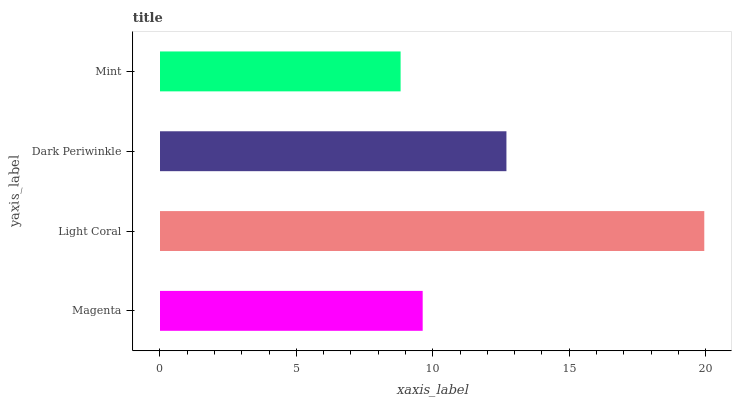Is Mint the minimum?
Answer yes or no. Yes. Is Light Coral the maximum?
Answer yes or no. Yes. Is Dark Periwinkle the minimum?
Answer yes or no. No. Is Dark Periwinkle the maximum?
Answer yes or no. No. Is Light Coral greater than Dark Periwinkle?
Answer yes or no. Yes. Is Dark Periwinkle less than Light Coral?
Answer yes or no. Yes. Is Dark Periwinkle greater than Light Coral?
Answer yes or no. No. Is Light Coral less than Dark Periwinkle?
Answer yes or no. No. Is Dark Periwinkle the high median?
Answer yes or no. Yes. Is Magenta the low median?
Answer yes or no. Yes. Is Mint the high median?
Answer yes or no. No. Is Mint the low median?
Answer yes or no. No. 